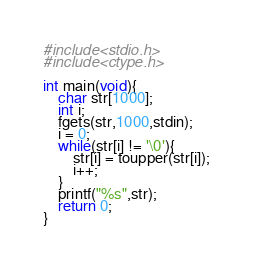<code> <loc_0><loc_0><loc_500><loc_500><_C_>#include<stdio.h>
#include<ctype.h>

int main(void){
	char str[1000];
	int i;
	fgets(str,1000,stdin);
	i = 0;
	while(str[i] != '\0'){
		str[i] = toupper(str[i]);
		i++;
	}
	printf("%s",str);
	return 0;
}</code> 